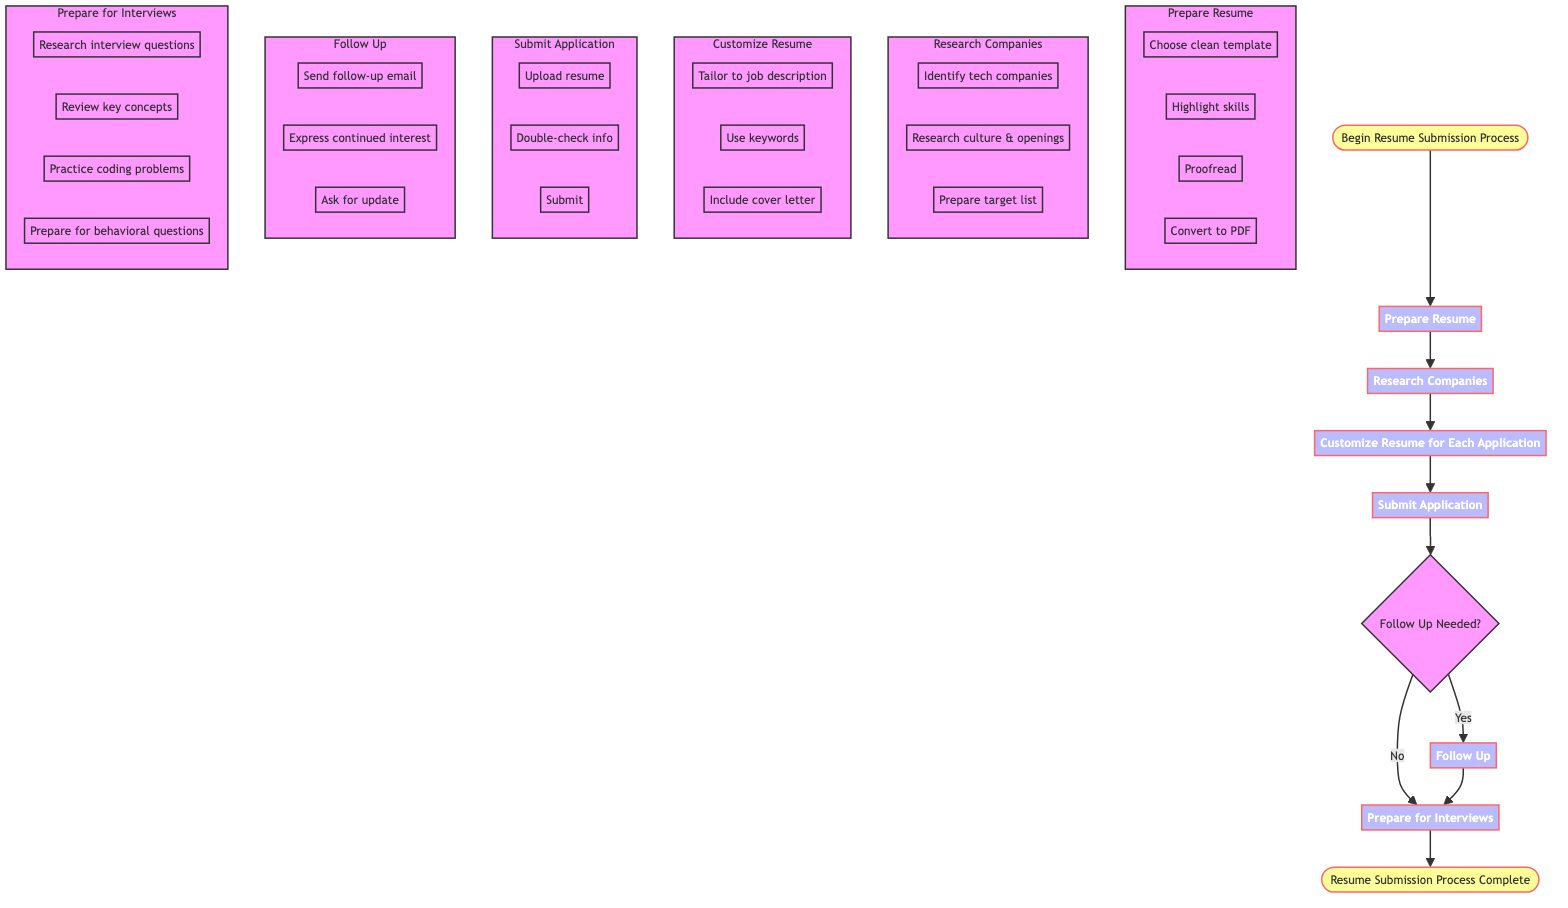What is the first step in the diagram? The first step is indicated by the arrow pointing from the "Begin Resume Submission Process" node to the "Prepare Resume" node.
Answer: Prepare Resume How many steps are there in the resume submission process? By counting each distinct process node leading from the start to the end, there are six main steps (Prepare Resume, Research Companies, Customize Resume for Each Application, Submit Application, Follow Up, Prepare for Interviews).
Answer: Six What action is taken after submitting the application? After "Submit Application," the flowchart indicates a decision node labeled "Follow Up Needed?" This determines the next action based on whether a follow-up is required or not.
Answer: Follow Up Needed? What does the "Follow Up" step include? The "Follow Up" step consists of three detailed actions: sending a follow-up email, expressing continued interest, and asking for an update on application status, as represented in the subgraph for Follow Up.
Answer: Send follow-up email, express continued interest, ask for update What is the last step before the process is complete? In the flowchart, the last step before reaching the "Resume Submission Process Complete" node is "Prepare for Interviews." This means that after preparing for interviews, the process wraps up with completion.
Answer: Prepare for Interviews What do you do if no response is received within 1-2 weeks? The diagram specifies that in such a case, the action is to send a follow-up email. This connects decision-making with timely communication.
Answer: Send a follow-up email What are the key activities involved in preparing a resume? In the "Prepare Resume" subgraph, key activities include choosing a clean template, highlighting skills, proofreading, and converting to PDF, all of which are necessary to make a solid application.
Answer: Choose clean template, highlight skills, proofread, convert to PDF Which step involves tailoring the resume? The "Customize Resume for Each Application" step includes the activity of tailoring the resume specifically for the job description, along with using keywords and including a cover letter if requested.
Answer: Customize Resume for Each Application What are some aspects to research in the company selection process? The "Research Companies" step advises identifying tech companies, researching their culture, and preparing a target list, all of which help in better matching with desired employers.
Answer: Identify tech companies, research culture & openings, prepare target list 